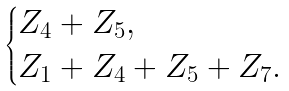Convert formula to latex. <formula><loc_0><loc_0><loc_500><loc_500>\begin{cases} Z _ { 4 } + Z _ { 5 } , \\ Z _ { 1 } + Z _ { 4 } + Z _ { 5 } + Z _ { 7 } . \end{cases}</formula> 